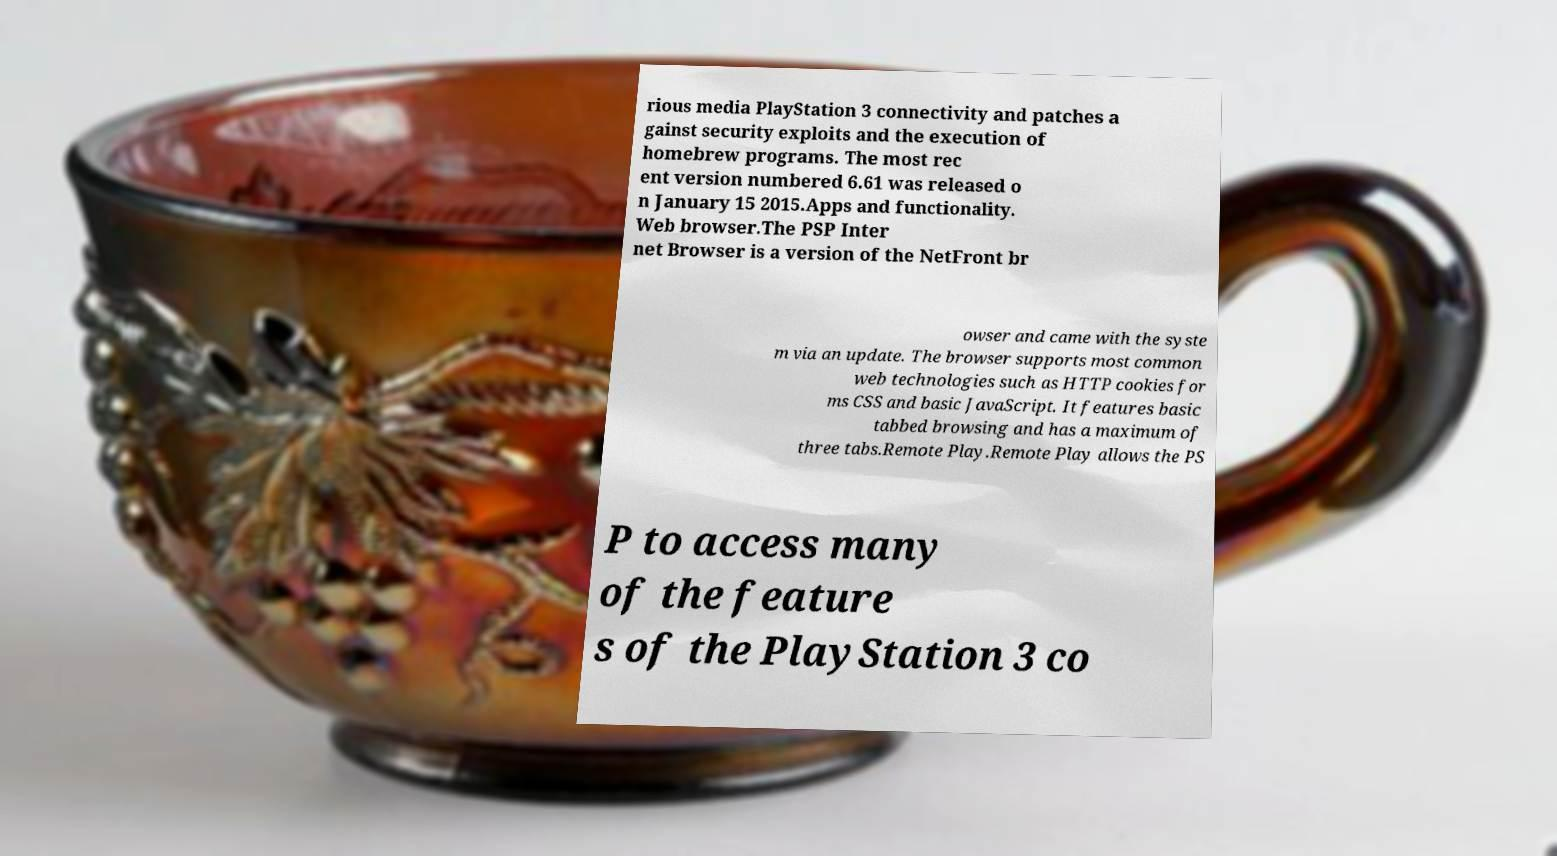There's text embedded in this image that I need extracted. Can you transcribe it verbatim? rious media PlayStation 3 connectivity and patches a gainst security exploits and the execution of homebrew programs. The most rec ent version numbered 6.61 was released o n January 15 2015.Apps and functionality. Web browser.The PSP Inter net Browser is a version of the NetFront br owser and came with the syste m via an update. The browser supports most common web technologies such as HTTP cookies for ms CSS and basic JavaScript. It features basic tabbed browsing and has a maximum of three tabs.Remote Play.Remote Play allows the PS P to access many of the feature s of the PlayStation 3 co 